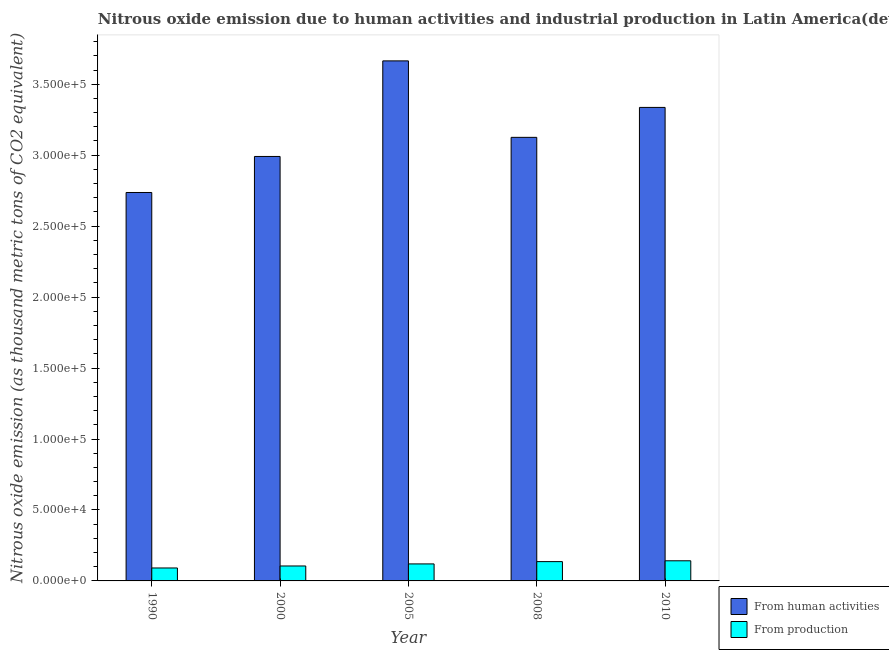How many different coloured bars are there?
Make the answer very short. 2. How many groups of bars are there?
Offer a very short reply. 5. How many bars are there on the 3rd tick from the left?
Ensure brevity in your answer.  2. What is the label of the 5th group of bars from the left?
Make the answer very short. 2010. In how many cases, is the number of bars for a given year not equal to the number of legend labels?
Ensure brevity in your answer.  0. What is the amount of emissions from human activities in 2008?
Provide a short and direct response. 3.13e+05. Across all years, what is the maximum amount of emissions from human activities?
Offer a terse response. 3.66e+05. Across all years, what is the minimum amount of emissions from human activities?
Your response must be concise. 2.74e+05. In which year was the amount of emissions from human activities maximum?
Offer a very short reply. 2005. In which year was the amount of emissions from human activities minimum?
Offer a very short reply. 1990. What is the total amount of emissions from human activities in the graph?
Your answer should be compact. 1.59e+06. What is the difference between the amount of emissions generated from industries in 2005 and that in 2008?
Give a very brief answer. -1623.8. What is the difference between the amount of emissions from human activities in 2000 and the amount of emissions generated from industries in 2010?
Provide a succinct answer. -3.46e+04. What is the average amount of emissions from human activities per year?
Offer a terse response. 3.17e+05. In the year 2010, what is the difference between the amount of emissions from human activities and amount of emissions generated from industries?
Provide a succinct answer. 0. What is the ratio of the amount of emissions from human activities in 1990 to that in 2008?
Your answer should be very brief. 0.88. Is the amount of emissions from human activities in 2000 less than that in 2005?
Your answer should be compact. Yes. Is the difference between the amount of emissions from human activities in 1990 and 2008 greater than the difference between the amount of emissions generated from industries in 1990 and 2008?
Offer a terse response. No. What is the difference between the highest and the second highest amount of emissions from human activities?
Your answer should be very brief. 3.28e+04. What is the difference between the highest and the lowest amount of emissions generated from industries?
Your answer should be very brief. 5058. Is the sum of the amount of emissions generated from industries in 1990 and 2010 greater than the maximum amount of emissions from human activities across all years?
Keep it short and to the point. Yes. What does the 2nd bar from the left in 2000 represents?
Provide a succinct answer. From production. What does the 1st bar from the right in 2010 represents?
Offer a very short reply. From production. How many bars are there?
Keep it short and to the point. 10. How many years are there in the graph?
Offer a terse response. 5. What is the difference between two consecutive major ticks on the Y-axis?
Provide a succinct answer. 5.00e+04. Are the values on the major ticks of Y-axis written in scientific E-notation?
Keep it short and to the point. Yes. Does the graph contain any zero values?
Your response must be concise. No. How are the legend labels stacked?
Your answer should be very brief. Vertical. What is the title of the graph?
Provide a short and direct response. Nitrous oxide emission due to human activities and industrial production in Latin America(developing only). Does "Enforce a contract" appear as one of the legend labels in the graph?
Provide a short and direct response. No. What is the label or title of the X-axis?
Make the answer very short. Year. What is the label or title of the Y-axis?
Offer a terse response. Nitrous oxide emission (as thousand metric tons of CO2 equivalent). What is the Nitrous oxide emission (as thousand metric tons of CO2 equivalent) in From human activities in 1990?
Make the answer very short. 2.74e+05. What is the Nitrous oxide emission (as thousand metric tons of CO2 equivalent) of From production in 1990?
Give a very brief answer. 9123.8. What is the Nitrous oxide emission (as thousand metric tons of CO2 equivalent) in From human activities in 2000?
Provide a succinct answer. 2.99e+05. What is the Nitrous oxide emission (as thousand metric tons of CO2 equivalent) of From production in 2000?
Provide a short and direct response. 1.05e+04. What is the Nitrous oxide emission (as thousand metric tons of CO2 equivalent) of From human activities in 2005?
Your response must be concise. 3.66e+05. What is the Nitrous oxide emission (as thousand metric tons of CO2 equivalent) of From production in 2005?
Your answer should be compact. 1.20e+04. What is the Nitrous oxide emission (as thousand metric tons of CO2 equivalent) in From human activities in 2008?
Give a very brief answer. 3.13e+05. What is the Nitrous oxide emission (as thousand metric tons of CO2 equivalent) of From production in 2008?
Give a very brief answer. 1.36e+04. What is the Nitrous oxide emission (as thousand metric tons of CO2 equivalent) in From human activities in 2010?
Your answer should be compact. 3.34e+05. What is the Nitrous oxide emission (as thousand metric tons of CO2 equivalent) of From production in 2010?
Your response must be concise. 1.42e+04. Across all years, what is the maximum Nitrous oxide emission (as thousand metric tons of CO2 equivalent) in From human activities?
Your answer should be very brief. 3.66e+05. Across all years, what is the maximum Nitrous oxide emission (as thousand metric tons of CO2 equivalent) of From production?
Your answer should be compact. 1.42e+04. Across all years, what is the minimum Nitrous oxide emission (as thousand metric tons of CO2 equivalent) in From human activities?
Your response must be concise. 2.74e+05. Across all years, what is the minimum Nitrous oxide emission (as thousand metric tons of CO2 equivalent) of From production?
Give a very brief answer. 9123.8. What is the total Nitrous oxide emission (as thousand metric tons of CO2 equivalent) in From human activities in the graph?
Your answer should be very brief. 1.59e+06. What is the total Nitrous oxide emission (as thousand metric tons of CO2 equivalent) of From production in the graph?
Your answer should be compact. 5.94e+04. What is the difference between the Nitrous oxide emission (as thousand metric tons of CO2 equivalent) in From human activities in 1990 and that in 2000?
Ensure brevity in your answer.  -2.54e+04. What is the difference between the Nitrous oxide emission (as thousand metric tons of CO2 equivalent) in From production in 1990 and that in 2000?
Give a very brief answer. -1404.8. What is the difference between the Nitrous oxide emission (as thousand metric tons of CO2 equivalent) of From human activities in 1990 and that in 2005?
Provide a succinct answer. -9.27e+04. What is the difference between the Nitrous oxide emission (as thousand metric tons of CO2 equivalent) of From production in 1990 and that in 2005?
Your answer should be very brief. -2858. What is the difference between the Nitrous oxide emission (as thousand metric tons of CO2 equivalent) in From human activities in 1990 and that in 2008?
Your answer should be compact. -3.89e+04. What is the difference between the Nitrous oxide emission (as thousand metric tons of CO2 equivalent) of From production in 1990 and that in 2008?
Provide a short and direct response. -4481.8. What is the difference between the Nitrous oxide emission (as thousand metric tons of CO2 equivalent) in From human activities in 1990 and that in 2010?
Keep it short and to the point. -6.00e+04. What is the difference between the Nitrous oxide emission (as thousand metric tons of CO2 equivalent) of From production in 1990 and that in 2010?
Make the answer very short. -5058. What is the difference between the Nitrous oxide emission (as thousand metric tons of CO2 equivalent) in From human activities in 2000 and that in 2005?
Make the answer very short. -6.74e+04. What is the difference between the Nitrous oxide emission (as thousand metric tons of CO2 equivalent) in From production in 2000 and that in 2005?
Provide a short and direct response. -1453.2. What is the difference between the Nitrous oxide emission (as thousand metric tons of CO2 equivalent) in From human activities in 2000 and that in 2008?
Provide a succinct answer. -1.35e+04. What is the difference between the Nitrous oxide emission (as thousand metric tons of CO2 equivalent) of From production in 2000 and that in 2008?
Your answer should be compact. -3077. What is the difference between the Nitrous oxide emission (as thousand metric tons of CO2 equivalent) of From human activities in 2000 and that in 2010?
Offer a terse response. -3.46e+04. What is the difference between the Nitrous oxide emission (as thousand metric tons of CO2 equivalent) in From production in 2000 and that in 2010?
Make the answer very short. -3653.2. What is the difference between the Nitrous oxide emission (as thousand metric tons of CO2 equivalent) of From human activities in 2005 and that in 2008?
Your answer should be compact. 5.39e+04. What is the difference between the Nitrous oxide emission (as thousand metric tons of CO2 equivalent) of From production in 2005 and that in 2008?
Provide a succinct answer. -1623.8. What is the difference between the Nitrous oxide emission (as thousand metric tons of CO2 equivalent) in From human activities in 2005 and that in 2010?
Provide a succinct answer. 3.28e+04. What is the difference between the Nitrous oxide emission (as thousand metric tons of CO2 equivalent) of From production in 2005 and that in 2010?
Provide a short and direct response. -2200. What is the difference between the Nitrous oxide emission (as thousand metric tons of CO2 equivalent) of From human activities in 2008 and that in 2010?
Keep it short and to the point. -2.11e+04. What is the difference between the Nitrous oxide emission (as thousand metric tons of CO2 equivalent) in From production in 2008 and that in 2010?
Your answer should be compact. -576.2. What is the difference between the Nitrous oxide emission (as thousand metric tons of CO2 equivalent) of From human activities in 1990 and the Nitrous oxide emission (as thousand metric tons of CO2 equivalent) of From production in 2000?
Offer a very short reply. 2.63e+05. What is the difference between the Nitrous oxide emission (as thousand metric tons of CO2 equivalent) of From human activities in 1990 and the Nitrous oxide emission (as thousand metric tons of CO2 equivalent) of From production in 2005?
Ensure brevity in your answer.  2.62e+05. What is the difference between the Nitrous oxide emission (as thousand metric tons of CO2 equivalent) of From human activities in 1990 and the Nitrous oxide emission (as thousand metric tons of CO2 equivalent) of From production in 2008?
Keep it short and to the point. 2.60e+05. What is the difference between the Nitrous oxide emission (as thousand metric tons of CO2 equivalent) of From human activities in 1990 and the Nitrous oxide emission (as thousand metric tons of CO2 equivalent) of From production in 2010?
Offer a terse response. 2.60e+05. What is the difference between the Nitrous oxide emission (as thousand metric tons of CO2 equivalent) of From human activities in 2000 and the Nitrous oxide emission (as thousand metric tons of CO2 equivalent) of From production in 2005?
Your answer should be compact. 2.87e+05. What is the difference between the Nitrous oxide emission (as thousand metric tons of CO2 equivalent) of From human activities in 2000 and the Nitrous oxide emission (as thousand metric tons of CO2 equivalent) of From production in 2008?
Ensure brevity in your answer.  2.85e+05. What is the difference between the Nitrous oxide emission (as thousand metric tons of CO2 equivalent) of From human activities in 2000 and the Nitrous oxide emission (as thousand metric tons of CO2 equivalent) of From production in 2010?
Make the answer very short. 2.85e+05. What is the difference between the Nitrous oxide emission (as thousand metric tons of CO2 equivalent) of From human activities in 2005 and the Nitrous oxide emission (as thousand metric tons of CO2 equivalent) of From production in 2008?
Keep it short and to the point. 3.53e+05. What is the difference between the Nitrous oxide emission (as thousand metric tons of CO2 equivalent) in From human activities in 2005 and the Nitrous oxide emission (as thousand metric tons of CO2 equivalent) in From production in 2010?
Your answer should be very brief. 3.52e+05. What is the difference between the Nitrous oxide emission (as thousand metric tons of CO2 equivalent) of From human activities in 2008 and the Nitrous oxide emission (as thousand metric tons of CO2 equivalent) of From production in 2010?
Give a very brief answer. 2.98e+05. What is the average Nitrous oxide emission (as thousand metric tons of CO2 equivalent) in From human activities per year?
Ensure brevity in your answer.  3.17e+05. What is the average Nitrous oxide emission (as thousand metric tons of CO2 equivalent) in From production per year?
Offer a terse response. 1.19e+04. In the year 1990, what is the difference between the Nitrous oxide emission (as thousand metric tons of CO2 equivalent) in From human activities and Nitrous oxide emission (as thousand metric tons of CO2 equivalent) in From production?
Keep it short and to the point. 2.65e+05. In the year 2000, what is the difference between the Nitrous oxide emission (as thousand metric tons of CO2 equivalent) in From human activities and Nitrous oxide emission (as thousand metric tons of CO2 equivalent) in From production?
Offer a terse response. 2.89e+05. In the year 2005, what is the difference between the Nitrous oxide emission (as thousand metric tons of CO2 equivalent) of From human activities and Nitrous oxide emission (as thousand metric tons of CO2 equivalent) of From production?
Your answer should be compact. 3.54e+05. In the year 2008, what is the difference between the Nitrous oxide emission (as thousand metric tons of CO2 equivalent) in From human activities and Nitrous oxide emission (as thousand metric tons of CO2 equivalent) in From production?
Your answer should be compact. 2.99e+05. In the year 2010, what is the difference between the Nitrous oxide emission (as thousand metric tons of CO2 equivalent) in From human activities and Nitrous oxide emission (as thousand metric tons of CO2 equivalent) in From production?
Provide a succinct answer. 3.19e+05. What is the ratio of the Nitrous oxide emission (as thousand metric tons of CO2 equivalent) of From human activities in 1990 to that in 2000?
Provide a succinct answer. 0.92. What is the ratio of the Nitrous oxide emission (as thousand metric tons of CO2 equivalent) of From production in 1990 to that in 2000?
Your answer should be compact. 0.87. What is the ratio of the Nitrous oxide emission (as thousand metric tons of CO2 equivalent) in From human activities in 1990 to that in 2005?
Make the answer very short. 0.75. What is the ratio of the Nitrous oxide emission (as thousand metric tons of CO2 equivalent) in From production in 1990 to that in 2005?
Keep it short and to the point. 0.76. What is the ratio of the Nitrous oxide emission (as thousand metric tons of CO2 equivalent) of From human activities in 1990 to that in 2008?
Your answer should be very brief. 0.88. What is the ratio of the Nitrous oxide emission (as thousand metric tons of CO2 equivalent) in From production in 1990 to that in 2008?
Your response must be concise. 0.67. What is the ratio of the Nitrous oxide emission (as thousand metric tons of CO2 equivalent) of From human activities in 1990 to that in 2010?
Make the answer very short. 0.82. What is the ratio of the Nitrous oxide emission (as thousand metric tons of CO2 equivalent) in From production in 1990 to that in 2010?
Provide a short and direct response. 0.64. What is the ratio of the Nitrous oxide emission (as thousand metric tons of CO2 equivalent) in From human activities in 2000 to that in 2005?
Offer a terse response. 0.82. What is the ratio of the Nitrous oxide emission (as thousand metric tons of CO2 equivalent) of From production in 2000 to that in 2005?
Offer a terse response. 0.88. What is the ratio of the Nitrous oxide emission (as thousand metric tons of CO2 equivalent) in From human activities in 2000 to that in 2008?
Offer a very short reply. 0.96. What is the ratio of the Nitrous oxide emission (as thousand metric tons of CO2 equivalent) of From production in 2000 to that in 2008?
Keep it short and to the point. 0.77. What is the ratio of the Nitrous oxide emission (as thousand metric tons of CO2 equivalent) of From human activities in 2000 to that in 2010?
Keep it short and to the point. 0.9. What is the ratio of the Nitrous oxide emission (as thousand metric tons of CO2 equivalent) in From production in 2000 to that in 2010?
Provide a succinct answer. 0.74. What is the ratio of the Nitrous oxide emission (as thousand metric tons of CO2 equivalent) of From human activities in 2005 to that in 2008?
Ensure brevity in your answer.  1.17. What is the ratio of the Nitrous oxide emission (as thousand metric tons of CO2 equivalent) in From production in 2005 to that in 2008?
Your response must be concise. 0.88. What is the ratio of the Nitrous oxide emission (as thousand metric tons of CO2 equivalent) in From human activities in 2005 to that in 2010?
Ensure brevity in your answer.  1.1. What is the ratio of the Nitrous oxide emission (as thousand metric tons of CO2 equivalent) of From production in 2005 to that in 2010?
Your answer should be very brief. 0.84. What is the ratio of the Nitrous oxide emission (as thousand metric tons of CO2 equivalent) of From human activities in 2008 to that in 2010?
Your answer should be very brief. 0.94. What is the ratio of the Nitrous oxide emission (as thousand metric tons of CO2 equivalent) of From production in 2008 to that in 2010?
Your response must be concise. 0.96. What is the difference between the highest and the second highest Nitrous oxide emission (as thousand metric tons of CO2 equivalent) in From human activities?
Ensure brevity in your answer.  3.28e+04. What is the difference between the highest and the second highest Nitrous oxide emission (as thousand metric tons of CO2 equivalent) in From production?
Offer a terse response. 576.2. What is the difference between the highest and the lowest Nitrous oxide emission (as thousand metric tons of CO2 equivalent) of From human activities?
Your answer should be compact. 9.27e+04. What is the difference between the highest and the lowest Nitrous oxide emission (as thousand metric tons of CO2 equivalent) of From production?
Ensure brevity in your answer.  5058. 